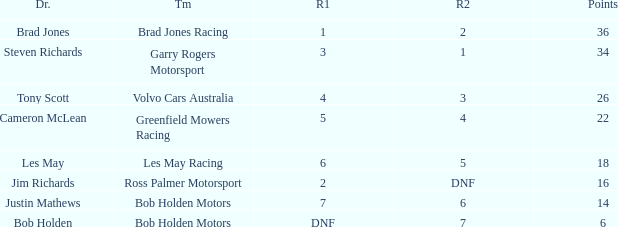Which driver for Bob Holden Motors has fewer than 36 points and placed 7 in race 1? Justin Mathews. 